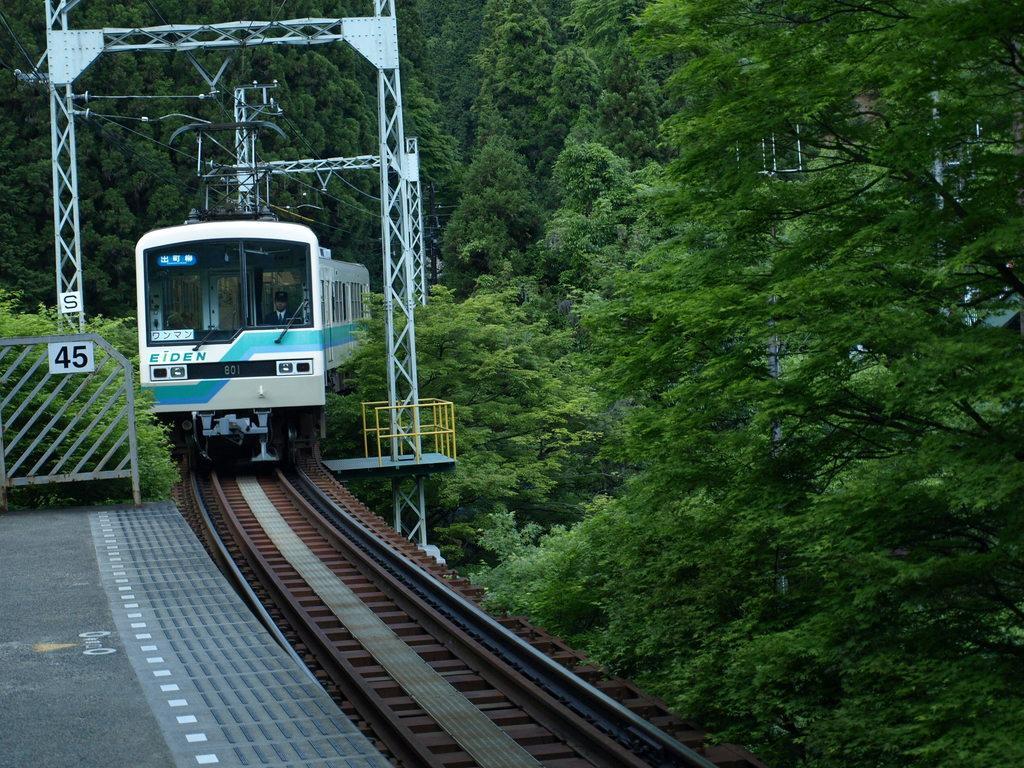How would you summarize this image in a sentence or two? In the image there is a train going on the track with plants on either side of it. 